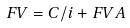<formula> <loc_0><loc_0><loc_500><loc_500>F V = C / i + F V A</formula> 